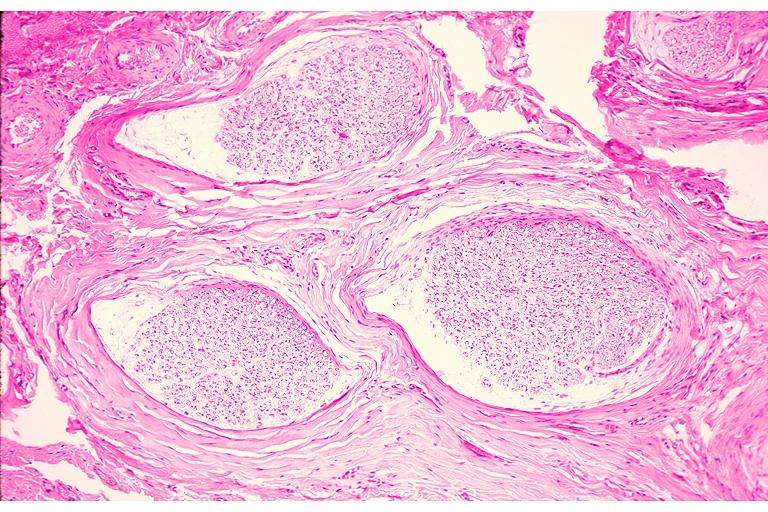where is this?
Answer the question using a single word or phrase. Oral 